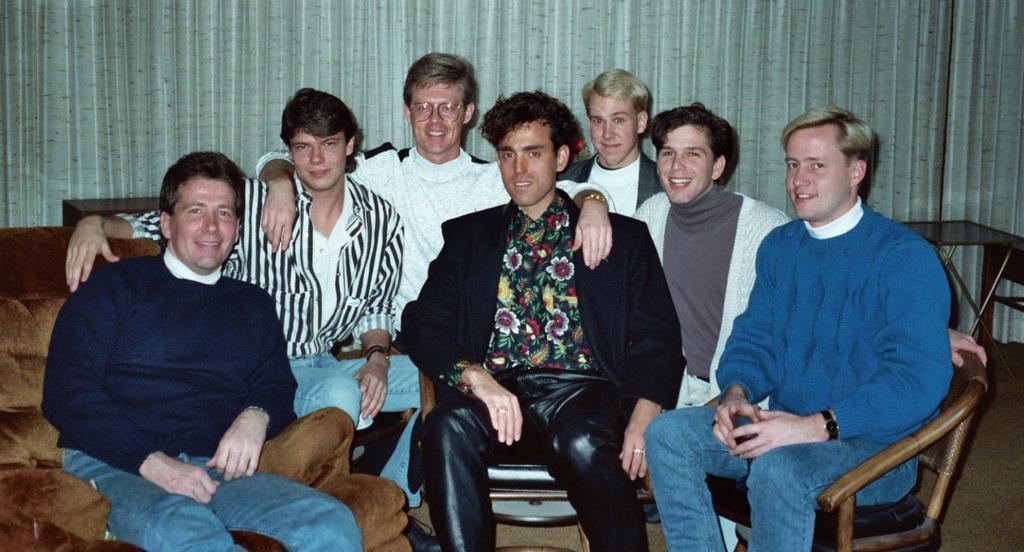Describe this image in one or two sentences. In this picture we can see few people are sitting on the chairs. This is sofa. And there is a table on the right side of the picture. This is floor and there is a curtain on the background. 